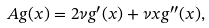<formula> <loc_0><loc_0><loc_500><loc_500>A g ( x ) = 2 \nu g ^ { \prime } ( x ) + \nu x g ^ { \prime \prime } ( x ) ,</formula> 